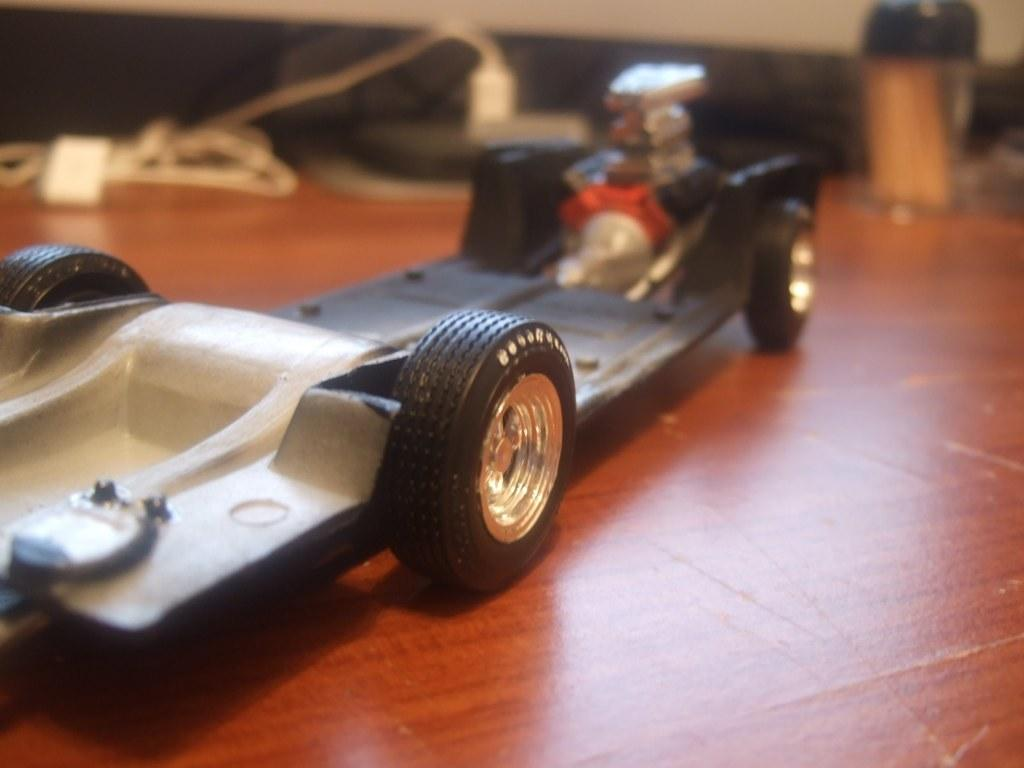What is the main object in the front of the image? There is a toy car in the front of the image. What can be seen in the background of the image? There are wires and an object that is black in color in the background of the image. Where is the box located in the image? The box is on the right side of the image. How many potatoes are visible in the image? There are no potatoes present in the image. 